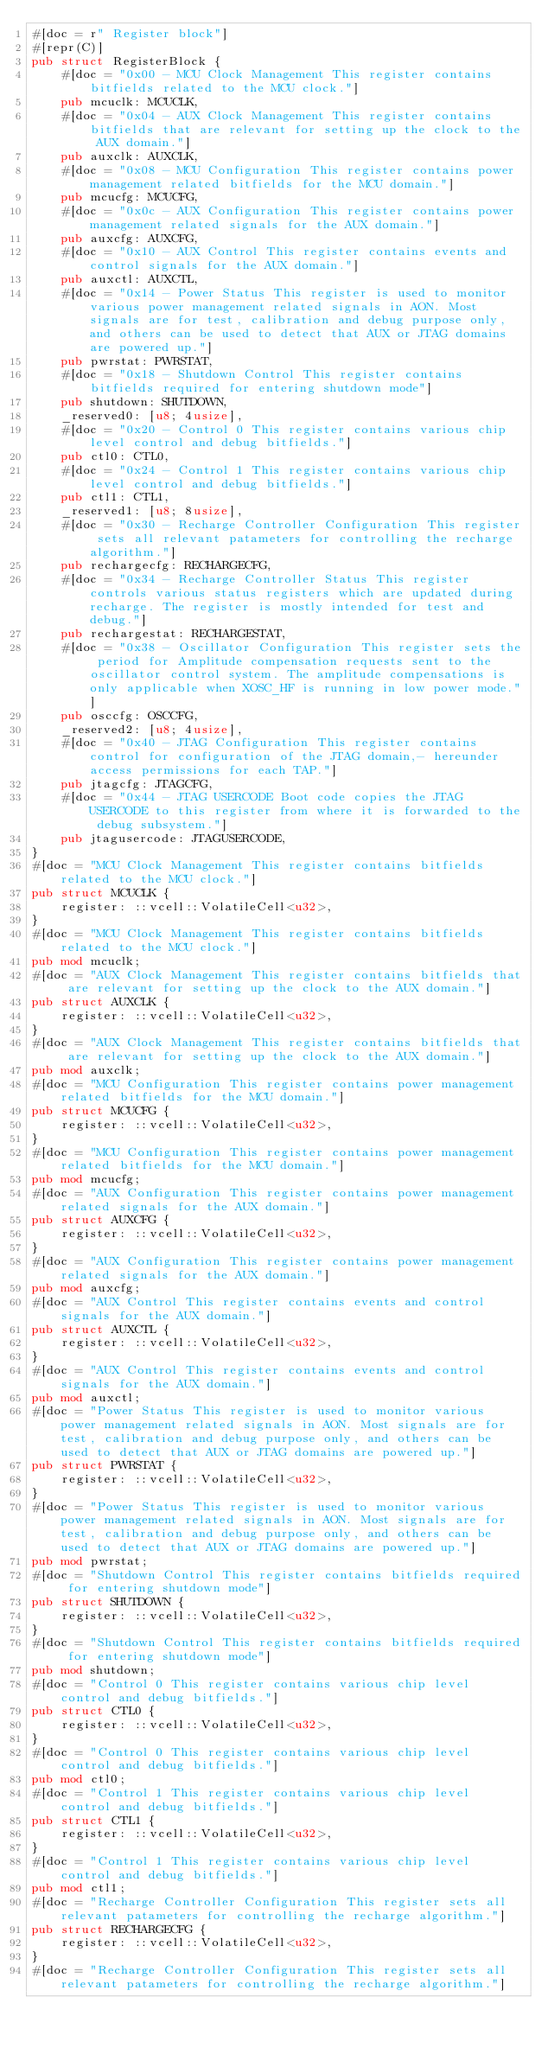Convert code to text. <code><loc_0><loc_0><loc_500><loc_500><_Rust_>#[doc = r" Register block"]
#[repr(C)]
pub struct RegisterBlock {
    #[doc = "0x00 - MCU Clock Management This register contains bitfields related to the MCU clock."]
    pub mcuclk: MCUCLK,
    #[doc = "0x04 - AUX Clock Management This register contains bitfields that are relevant for setting up the clock to the AUX domain."]
    pub auxclk: AUXCLK,
    #[doc = "0x08 - MCU Configuration This register contains power management related bitfields for the MCU domain."]
    pub mcucfg: MCUCFG,
    #[doc = "0x0c - AUX Configuration This register contains power management related signals for the AUX domain."]
    pub auxcfg: AUXCFG,
    #[doc = "0x10 - AUX Control This register contains events and control signals for the AUX domain."]
    pub auxctl: AUXCTL,
    #[doc = "0x14 - Power Status This register is used to monitor various power management related signals in AON. Most signals are for test, calibration and debug purpose only, and others can be used to detect that AUX or JTAG domains are powered up."]
    pub pwrstat: PWRSTAT,
    #[doc = "0x18 - Shutdown Control This register contains bitfields required for entering shutdown mode"]
    pub shutdown: SHUTDOWN,
    _reserved0: [u8; 4usize],
    #[doc = "0x20 - Control 0 This register contains various chip level control and debug bitfields."]
    pub ctl0: CTL0,
    #[doc = "0x24 - Control 1 This register contains various chip level control and debug bitfields."]
    pub ctl1: CTL1,
    _reserved1: [u8; 8usize],
    #[doc = "0x30 - Recharge Controller Configuration This register sets all relevant patameters for controlling the recharge algorithm."]
    pub rechargecfg: RECHARGECFG,
    #[doc = "0x34 - Recharge Controller Status This register controls various status registers which are updated during recharge. The register is mostly intended for test and debug."]
    pub rechargestat: RECHARGESTAT,
    #[doc = "0x38 - Oscillator Configuration This register sets the period for Amplitude compensation requests sent to the oscillator control system. The amplitude compensations is only applicable when XOSC_HF is running in low power mode."]
    pub osccfg: OSCCFG,
    _reserved2: [u8; 4usize],
    #[doc = "0x40 - JTAG Configuration This register contains control for configuration of the JTAG domain,- hereunder access permissions for each TAP."]
    pub jtagcfg: JTAGCFG,
    #[doc = "0x44 - JTAG USERCODE Boot code copies the JTAG USERCODE to this register from where it is forwarded to the debug subsystem."]
    pub jtagusercode: JTAGUSERCODE,
}
#[doc = "MCU Clock Management This register contains bitfields related to the MCU clock."]
pub struct MCUCLK {
    register: ::vcell::VolatileCell<u32>,
}
#[doc = "MCU Clock Management This register contains bitfields related to the MCU clock."]
pub mod mcuclk;
#[doc = "AUX Clock Management This register contains bitfields that are relevant for setting up the clock to the AUX domain."]
pub struct AUXCLK {
    register: ::vcell::VolatileCell<u32>,
}
#[doc = "AUX Clock Management This register contains bitfields that are relevant for setting up the clock to the AUX domain."]
pub mod auxclk;
#[doc = "MCU Configuration This register contains power management related bitfields for the MCU domain."]
pub struct MCUCFG {
    register: ::vcell::VolatileCell<u32>,
}
#[doc = "MCU Configuration This register contains power management related bitfields for the MCU domain."]
pub mod mcucfg;
#[doc = "AUX Configuration This register contains power management related signals for the AUX domain."]
pub struct AUXCFG {
    register: ::vcell::VolatileCell<u32>,
}
#[doc = "AUX Configuration This register contains power management related signals for the AUX domain."]
pub mod auxcfg;
#[doc = "AUX Control This register contains events and control signals for the AUX domain."]
pub struct AUXCTL {
    register: ::vcell::VolatileCell<u32>,
}
#[doc = "AUX Control This register contains events and control signals for the AUX domain."]
pub mod auxctl;
#[doc = "Power Status This register is used to monitor various power management related signals in AON. Most signals are for test, calibration and debug purpose only, and others can be used to detect that AUX or JTAG domains are powered up."]
pub struct PWRSTAT {
    register: ::vcell::VolatileCell<u32>,
}
#[doc = "Power Status This register is used to monitor various power management related signals in AON. Most signals are for test, calibration and debug purpose only, and others can be used to detect that AUX or JTAG domains are powered up."]
pub mod pwrstat;
#[doc = "Shutdown Control This register contains bitfields required for entering shutdown mode"]
pub struct SHUTDOWN {
    register: ::vcell::VolatileCell<u32>,
}
#[doc = "Shutdown Control This register contains bitfields required for entering shutdown mode"]
pub mod shutdown;
#[doc = "Control 0 This register contains various chip level control and debug bitfields."]
pub struct CTL0 {
    register: ::vcell::VolatileCell<u32>,
}
#[doc = "Control 0 This register contains various chip level control and debug bitfields."]
pub mod ctl0;
#[doc = "Control 1 This register contains various chip level control and debug bitfields."]
pub struct CTL1 {
    register: ::vcell::VolatileCell<u32>,
}
#[doc = "Control 1 This register contains various chip level control and debug bitfields."]
pub mod ctl1;
#[doc = "Recharge Controller Configuration This register sets all relevant patameters for controlling the recharge algorithm."]
pub struct RECHARGECFG {
    register: ::vcell::VolatileCell<u32>,
}
#[doc = "Recharge Controller Configuration This register sets all relevant patameters for controlling the recharge algorithm."]</code> 